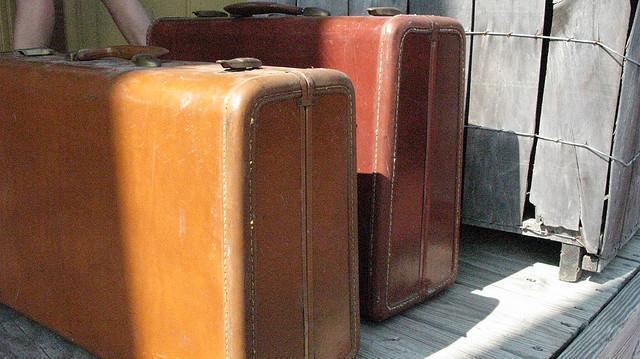How many suitcases are visible?
Give a very brief answer. 2. How many boys are in this photo?
Give a very brief answer. 0. 